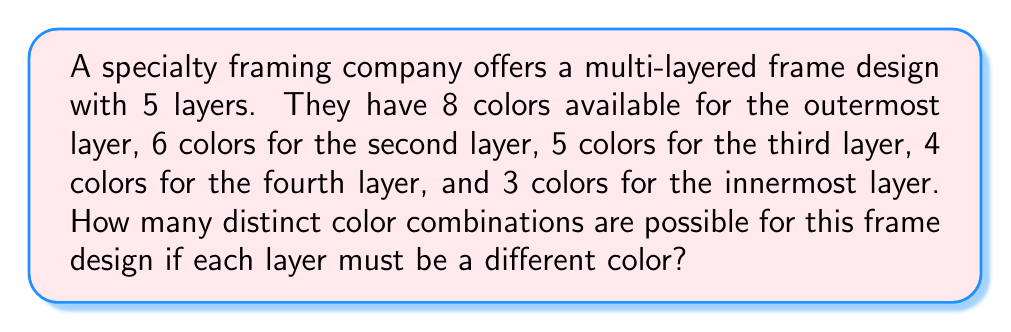Give your solution to this math problem. Let's approach this step-by-step:

1) For the outermost layer, we have 8 color choices.

2) For the second layer, we have 6 color choices, as it must be different from the outermost layer.

3) For the third layer, we have 5 color choices, as it must be different from the first two layers.

4) For the fourth layer, we have 4 color choices, as it must be different from the first three layers.

5) For the innermost layer, we have 3 color choices, as it must be different from all other layers.

6) According to the multiplication principle of counting, when we have a sequence of independent choices, we multiply the number of ways for each choice:

   $$8 \times 6 \times 5 \times 4 \times 3$$

7) Calculating this:
   $$8 \times 6 \times 5 \times 4 \times 3 = 2880$$

Therefore, there are 2880 distinct color combinations possible for this multi-layered frame design.
Answer: 2880 